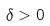Convert formula to latex. <formula><loc_0><loc_0><loc_500><loc_500>\delta > 0</formula> 